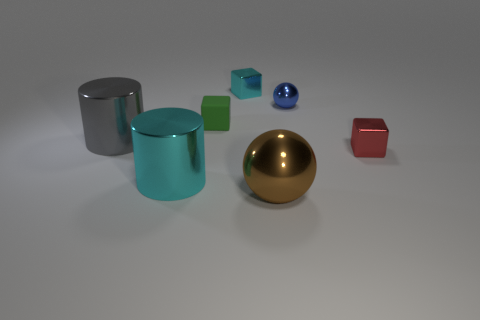There is a tiny cyan thing that is the same shape as the tiny red thing; what is its material?
Make the answer very short. Metal. There is a tiny red block; are there any matte objects on the right side of it?
Make the answer very short. No. Does the ball to the left of the small blue ball have the same material as the blue object?
Your answer should be compact. Yes. Is there a small rubber block of the same color as the small rubber thing?
Ensure brevity in your answer.  No. What is the shape of the red metallic object?
Your answer should be compact. Cube. What is the color of the metal sphere behind the shiny sphere left of the small metal sphere?
Ensure brevity in your answer.  Blue. What is the size of the metal ball in front of the tiny matte block?
Your answer should be compact. Large. Are there any other tiny blue spheres that have the same material as the tiny ball?
Provide a succinct answer. No. How many other tiny metallic objects have the same shape as the red shiny object?
Offer a very short reply. 1. What is the shape of the large object that is left of the cyan object in front of the small red metal thing that is to the right of the green block?
Offer a very short reply. Cylinder. 